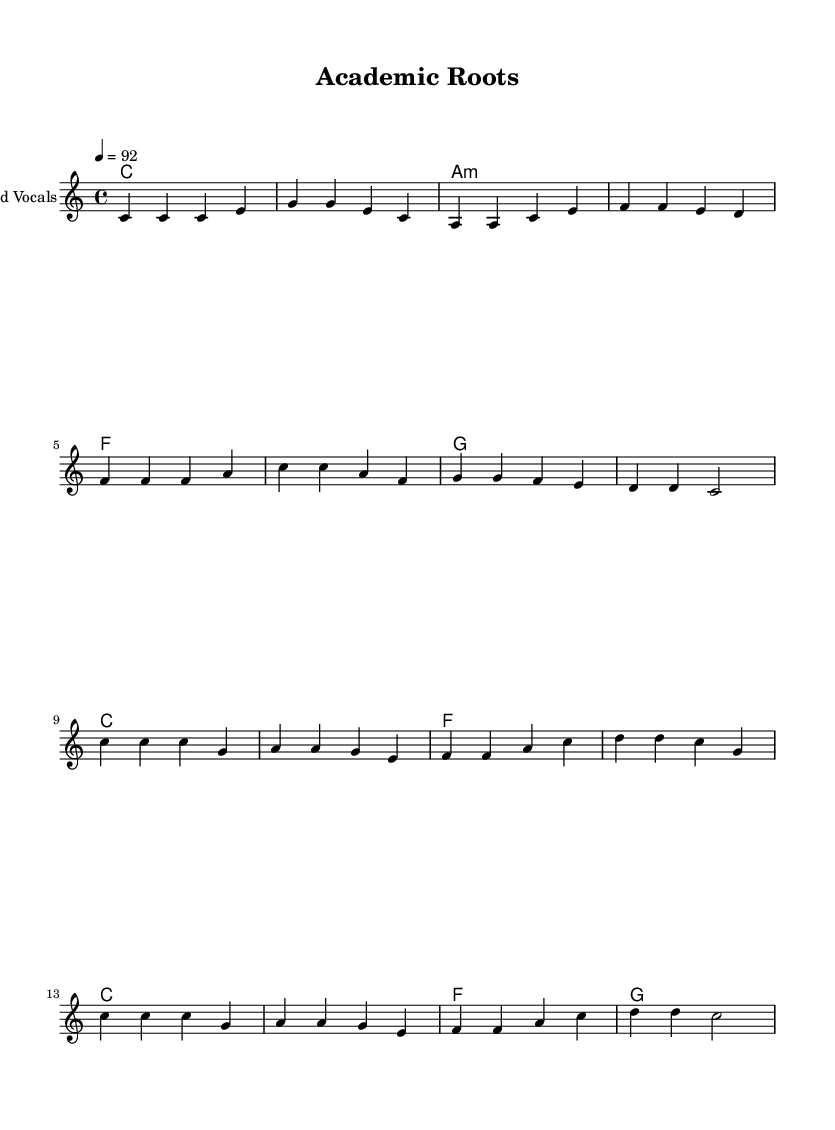What is the key signature of this music? The key signature is C major, which has no sharps or flats.
Answer: C major What is the time signature of this music? The time signature is indicated by the 4/4 at the beginning, which means there are four beats in each measure.
Answer: 4/4 What is the tempo marking of the piece? The tempo is indicated as 4 = 92, which means there are 92 quarter note beats per minute.
Answer: 92 How many measures are in the verse? The verse consists of a sequence of measures, and by counting the melody blocks, we find there are 8 measures.
Answer: 8 What is the final chord of the chorus? The final chord of the chorus can be identified in the chord section where the last symbol is 'g', indicating the last chord played is a G major chord.
Answer: G How does the message of the lyrics relate to the theme of perseverance? The lyrics emphasize determination in academic pursuits, repeating the notion of rising despite struggles, which aligns with the theme of perseverance.
Answer: Determination What genre is this music and what elements support that? The music is categorized as reggae, characterized by its offbeat rhythms and uplifting message in the lyrics.
Answer: Reggae 